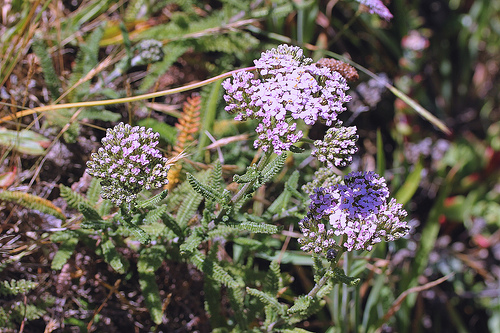<image>
Is the flowers in the bush? Yes. The flowers is contained within or inside the bush, showing a containment relationship. 